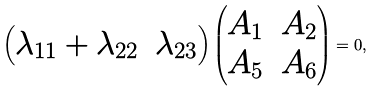Convert formula to latex. <formula><loc_0><loc_0><loc_500><loc_500>\begin{pmatrix} \lambda _ { 1 1 } + \lambda _ { 2 2 } & \lambda _ { 2 3 } \end{pmatrix} \begin{pmatrix} A _ { 1 } & A _ { 2 } \\ A _ { 5 } & A _ { 6 } \end{pmatrix} = 0 ,</formula> 